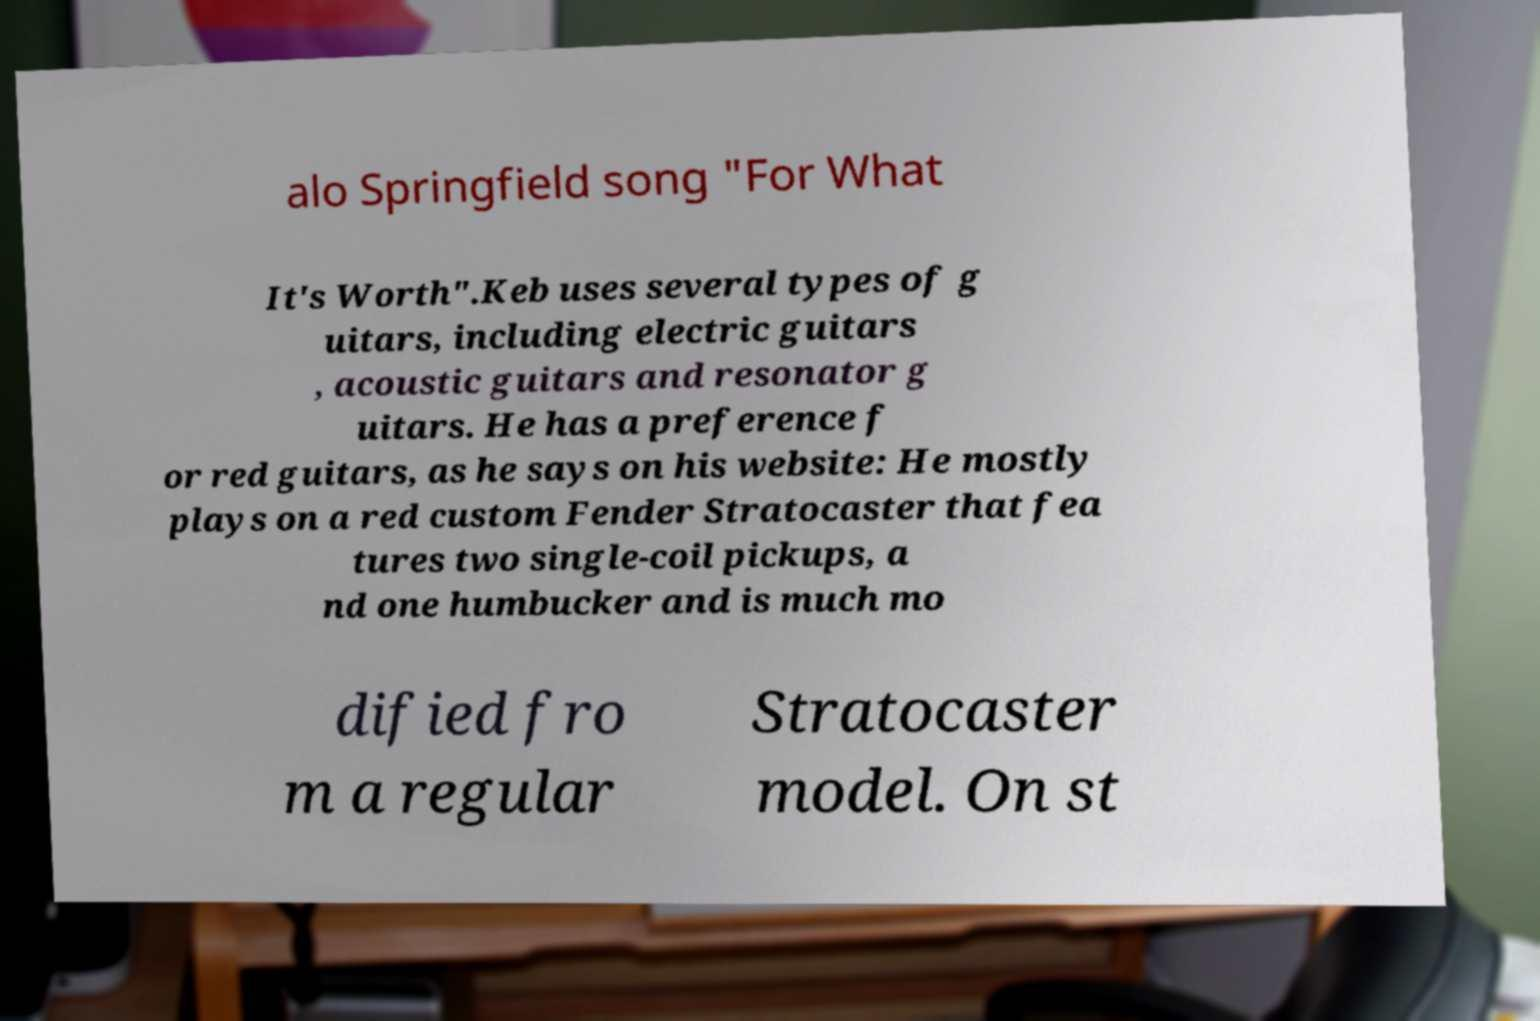Could you assist in decoding the text presented in this image and type it out clearly? alo Springfield song "For What It's Worth".Keb uses several types of g uitars, including electric guitars , acoustic guitars and resonator g uitars. He has a preference f or red guitars, as he says on his website: He mostly plays on a red custom Fender Stratocaster that fea tures two single-coil pickups, a nd one humbucker and is much mo dified fro m a regular Stratocaster model. On st 